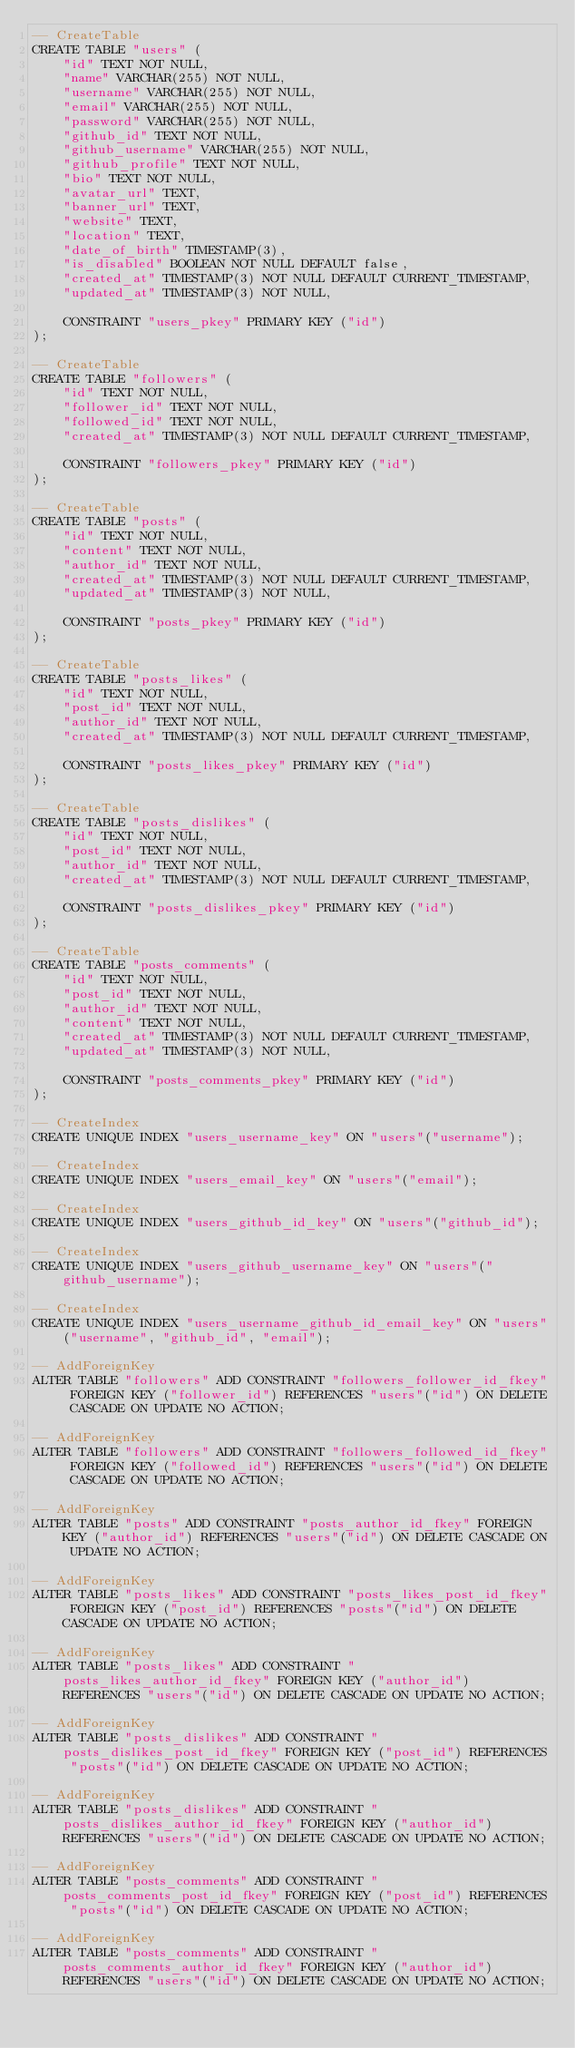Convert code to text. <code><loc_0><loc_0><loc_500><loc_500><_SQL_>-- CreateTable
CREATE TABLE "users" (
    "id" TEXT NOT NULL,
    "name" VARCHAR(255) NOT NULL,
    "username" VARCHAR(255) NOT NULL,
    "email" VARCHAR(255) NOT NULL,
    "password" VARCHAR(255) NOT NULL,
    "github_id" TEXT NOT NULL,
    "github_username" VARCHAR(255) NOT NULL,
    "github_profile" TEXT NOT NULL,
    "bio" TEXT NOT NULL,
    "avatar_url" TEXT,
    "banner_url" TEXT,
    "website" TEXT,
    "location" TEXT,
    "date_of_birth" TIMESTAMP(3),
    "is_disabled" BOOLEAN NOT NULL DEFAULT false,
    "created_at" TIMESTAMP(3) NOT NULL DEFAULT CURRENT_TIMESTAMP,
    "updated_at" TIMESTAMP(3) NOT NULL,

    CONSTRAINT "users_pkey" PRIMARY KEY ("id")
);

-- CreateTable
CREATE TABLE "followers" (
    "id" TEXT NOT NULL,
    "follower_id" TEXT NOT NULL,
    "followed_id" TEXT NOT NULL,
    "created_at" TIMESTAMP(3) NOT NULL DEFAULT CURRENT_TIMESTAMP,

    CONSTRAINT "followers_pkey" PRIMARY KEY ("id")
);

-- CreateTable
CREATE TABLE "posts" (
    "id" TEXT NOT NULL,
    "content" TEXT NOT NULL,
    "author_id" TEXT NOT NULL,
    "created_at" TIMESTAMP(3) NOT NULL DEFAULT CURRENT_TIMESTAMP,
    "updated_at" TIMESTAMP(3) NOT NULL,

    CONSTRAINT "posts_pkey" PRIMARY KEY ("id")
);

-- CreateTable
CREATE TABLE "posts_likes" (
    "id" TEXT NOT NULL,
    "post_id" TEXT NOT NULL,
    "author_id" TEXT NOT NULL,
    "created_at" TIMESTAMP(3) NOT NULL DEFAULT CURRENT_TIMESTAMP,

    CONSTRAINT "posts_likes_pkey" PRIMARY KEY ("id")
);

-- CreateTable
CREATE TABLE "posts_dislikes" (
    "id" TEXT NOT NULL,
    "post_id" TEXT NOT NULL,
    "author_id" TEXT NOT NULL,
    "created_at" TIMESTAMP(3) NOT NULL DEFAULT CURRENT_TIMESTAMP,

    CONSTRAINT "posts_dislikes_pkey" PRIMARY KEY ("id")
);

-- CreateTable
CREATE TABLE "posts_comments" (
    "id" TEXT NOT NULL,
    "post_id" TEXT NOT NULL,
    "author_id" TEXT NOT NULL,
    "content" TEXT NOT NULL,
    "created_at" TIMESTAMP(3) NOT NULL DEFAULT CURRENT_TIMESTAMP,
    "updated_at" TIMESTAMP(3) NOT NULL,

    CONSTRAINT "posts_comments_pkey" PRIMARY KEY ("id")
);

-- CreateIndex
CREATE UNIQUE INDEX "users_username_key" ON "users"("username");

-- CreateIndex
CREATE UNIQUE INDEX "users_email_key" ON "users"("email");

-- CreateIndex
CREATE UNIQUE INDEX "users_github_id_key" ON "users"("github_id");

-- CreateIndex
CREATE UNIQUE INDEX "users_github_username_key" ON "users"("github_username");

-- CreateIndex
CREATE UNIQUE INDEX "users_username_github_id_email_key" ON "users"("username", "github_id", "email");

-- AddForeignKey
ALTER TABLE "followers" ADD CONSTRAINT "followers_follower_id_fkey" FOREIGN KEY ("follower_id") REFERENCES "users"("id") ON DELETE CASCADE ON UPDATE NO ACTION;

-- AddForeignKey
ALTER TABLE "followers" ADD CONSTRAINT "followers_followed_id_fkey" FOREIGN KEY ("followed_id") REFERENCES "users"("id") ON DELETE CASCADE ON UPDATE NO ACTION;

-- AddForeignKey
ALTER TABLE "posts" ADD CONSTRAINT "posts_author_id_fkey" FOREIGN KEY ("author_id") REFERENCES "users"("id") ON DELETE CASCADE ON UPDATE NO ACTION;

-- AddForeignKey
ALTER TABLE "posts_likes" ADD CONSTRAINT "posts_likes_post_id_fkey" FOREIGN KEY ("post_id") REFERENCES "posts"("id") ON DELETE CASCADE ON UPDATE NO ACTION;

-- AddForeignKey
ALTER TABLE "posts_likes" ADD CONSTRAINT "posts_likes_author_id_fkey" FOREIGN KEY ("author_id") REFERENCES "users"("id") ON DELETE CASCADE ON UPDATE NO ACTION;

-- AddForeignKey
ALTER TABLE "posts_dislikes" ADD CONSTRAINT "posts_dislikes_post_id_fkey" FOREIGN KEY ("post_id") REFERENCES "posts"("id") ON DELETE CASCADE ON UPDATE NO ACTION;

-- AddForeignKey
ALTER TABLE "posts_dislikes" ADD CONSTRAINT "posts_dislikes_author_id_fkey" FOREIGN KEY ("author_id") REFERENCES "users"("id") ON DELETE CASCADE ON UPDATE NO ACTION;

-- AddForeignKey
ALTER TABLE "posts_comments" ADD CONSTRAINT "posts_comments_post_id_fkey" FOREIGN KEY ("post_id") REFERENCES "posts"("id") ON DELETE CASCADE ON UPDATE NO ACTION;

-- AddForeignKey
ALTER TABLE "posts_comments" ADD CONSTRAINT "posts_comments_author_id_fkey" FOREIGN KEY ("author_id") REFERENCES "users"("id") ON DELETE CASCADE ON UPDATE NO ACTION;
</code> 